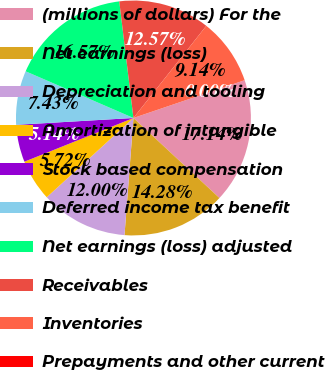Convert chart to OTSL. <chart><loc_0><loc_0><loc_500><loc_500><pie_chart><fcel>(millions of dollars) For the<fcel>Net earnings (loss)<fcel>Depreciation and tooling<fcel>Amortization of intangible<fcel>Stock based compensation<fcel>Deferred income tax benefit<fcel>Net earnings (loss) adjusted<fcel>Receivables<fcel>Inventories<fcel>Prepayments and other current<nl><fcel>17.14%<fcel>14.28%<fcel>12.0%<fcel>5.72%<fcel>5.14%<fcel>7.43%<fcel>16.57%<fcel>12.57%<fcel>9.14%<fcel>0.0%<nl></chart> 